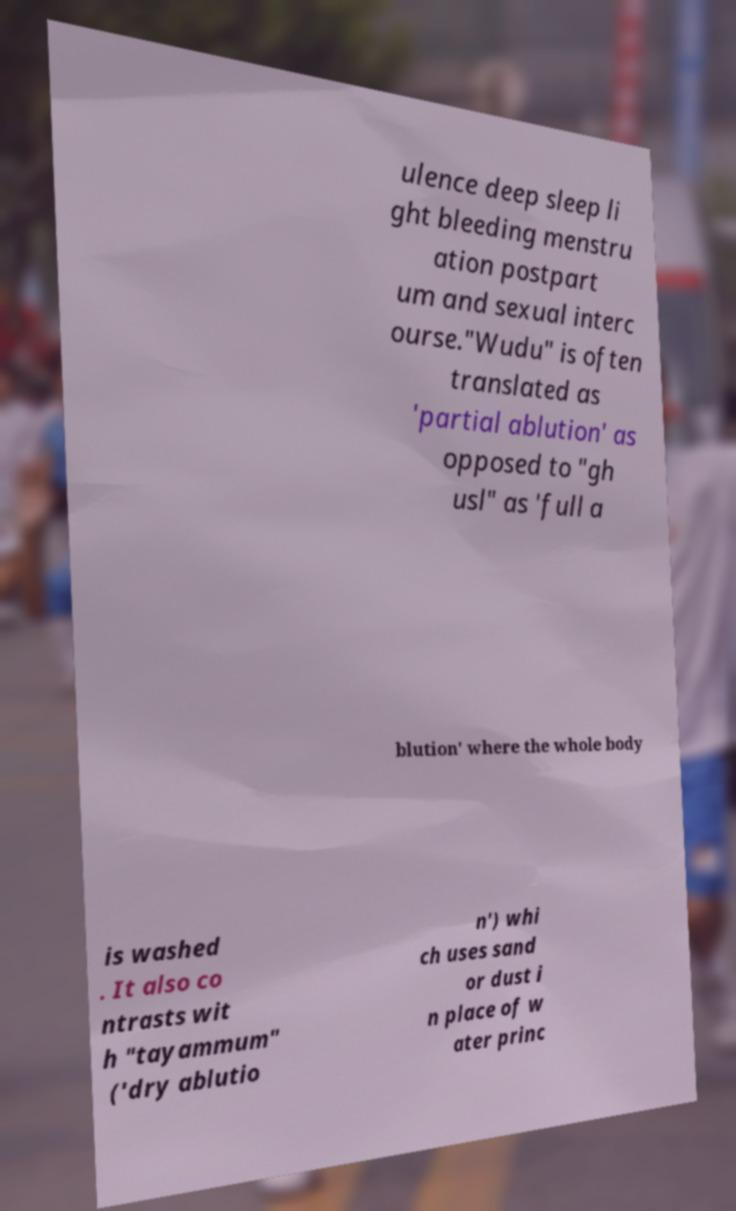Please identify and transcribe the text found in this image. ulence deep sleep li ght bleeding menstru ation postpart um and sexual interc ourse."Wudu" is often translated as 'partial ablution' as opposed to "gh usl" as 'full a blution' where the whole body is washed . It also co ntrasts wit h "tayammum" ('dry ablutio n') whi ch uses sand or dust i n place of w ater princ 